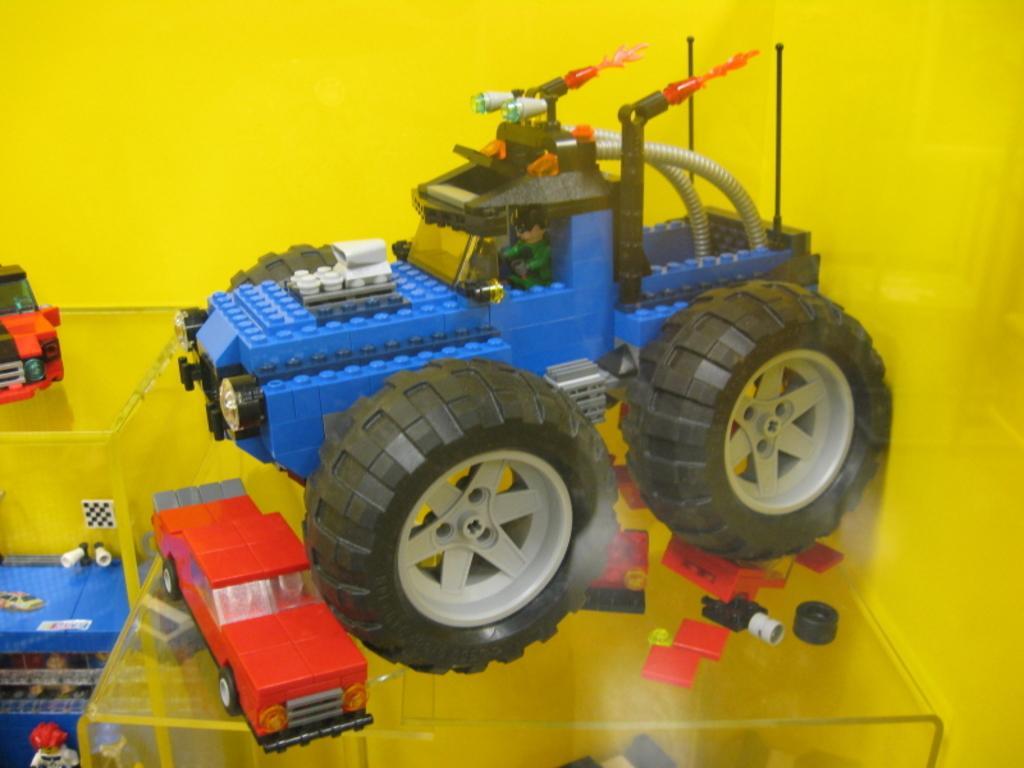Could you give a brief overview of what you see in this image? In this image, we can see toy cars on glass tables. 